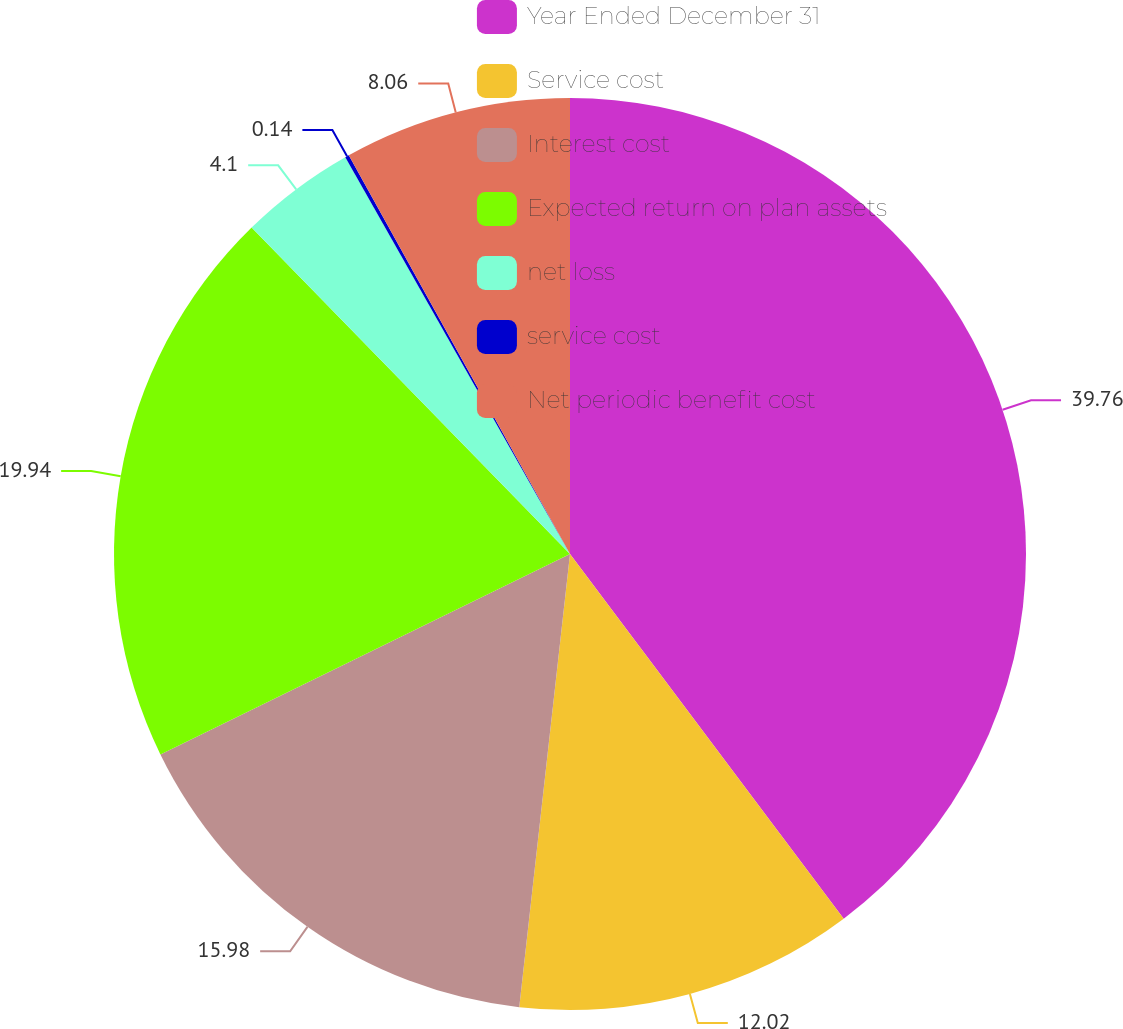Convert chart. <chart><loc_0><loc_0><loc_500><loc_500><pie_chart><fcel>Year Ended December 31<fcel>Service cost<fcel>Interest cost<fcel>Expected return on plan assets<fcel>net loss<fcel>service cost<fcel>Net periodic benefit cost<nl><fcel>39.75%<fcel>12.02%<fcel>15.98%<fcel>19.94%<fcel>4.1%<fcel>0.14%<fcel>8.06%<nl></chart> 